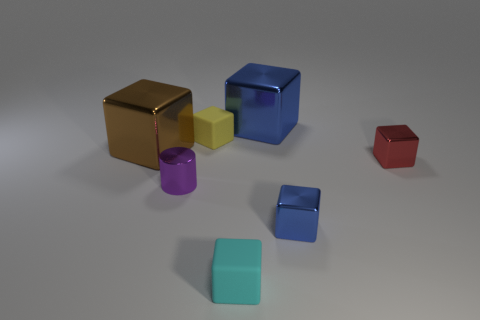Are there any blue things that have the same shape as the yellow matte object?
Make the answer very short. Yes. There is a large brown metal thing; does it have the same shape as the big blue thing on the right side of the purple cylinder?
Provide a succinct answer. Yes. There is a shiny object that is both in front of the red cube and on the right side of the metal cylinder; what is its size?
Provide a short and direct response. Small. What number of cubes are there?
Ensure brevity in your answer.  6. What is the material of the cyan block that is the same size as the red block?
Provide a short and direct response. Rubber. Are there any blue blocks of the same size as the cyan object?
Your response must be concise. Yes. There is a shiny block that is behind the brown shiny cube; does it have the same color as the shiny thing that is in front of the cylinder?
Offer a terse response. Yes. How many metal things are tiny purple cylinders or blue cubes?
Offer a very short reply. 3. What number of rubber blocks are behind the big cube left of the blue thing behind the big brown object?
Provide a succinct answer. 1. The brown thing that is made of the same material as the red block is what size?
Make the answer very short. Large. 